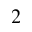<formula> <loc_0><loc_0><loc_500><loc_500>^ { 2 }</formula> 